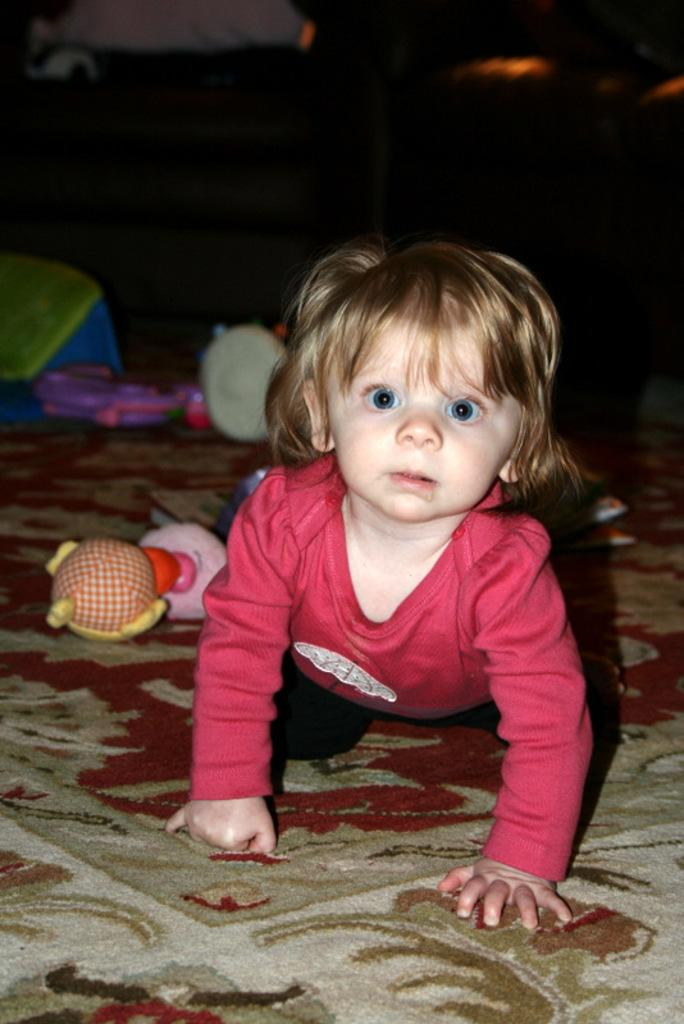What is the main subject of the picture? The main subject of the picture is a baby. What can be seen on the floor near the baby? There are toys on the carpet. How would you describe the lighting in the image? The background of the image is dark. What type of dress is the baby wearing in the image? There is no dress visible in the image, as the baby is not wearing any clothing. How many beginner-level books can be seen in the image? There are no books present in the image, so it is not possible to determine the level of any books. 